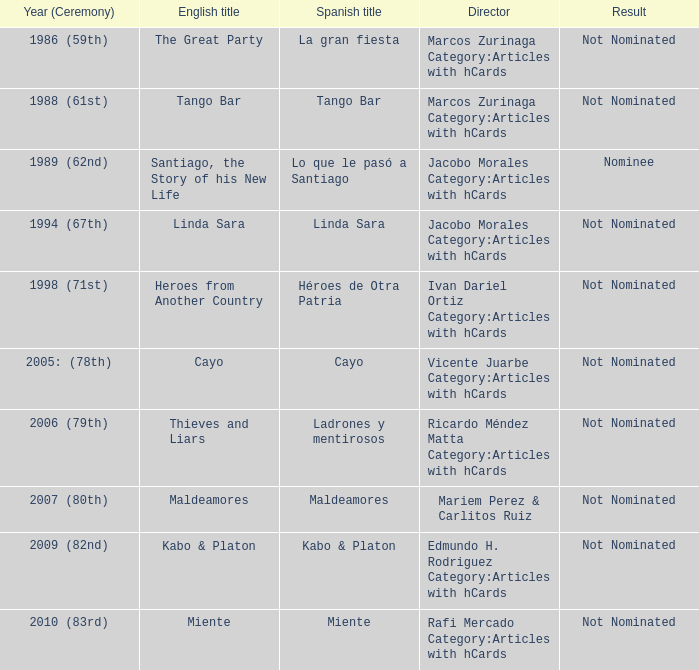What was the English title fo the film that was a nominee? Santiago, the Story of his New Life. 